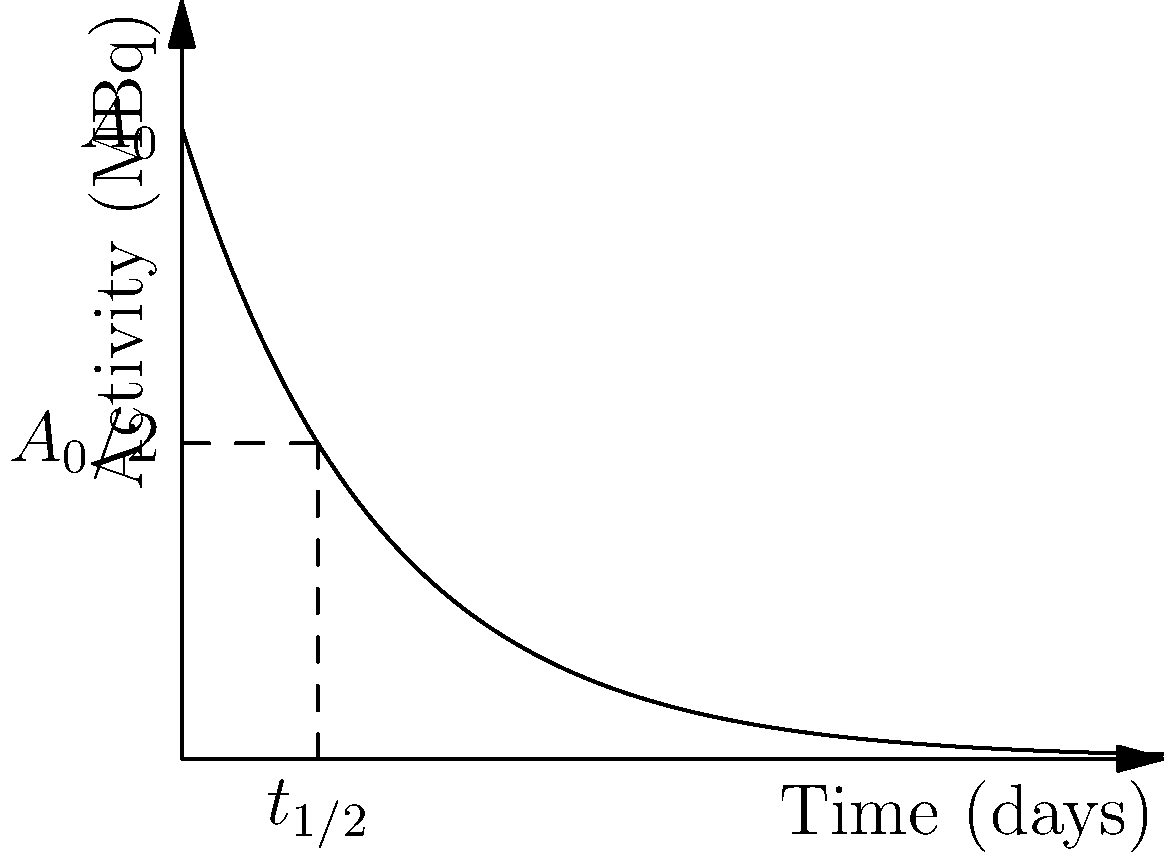A radioactive isotope used in medical treatments follows the decay curve shown in the graph. If the initial activity is 100 MBq, what will be the approximate activity after 20 days? How does this relate to the isotope's half-life? To solve this problem, we need to follow these steps:

1) First, we identify the decay constant $\lambda$ from the graph. The curve follows the equation $A(t) = A_0 e^{-\lambda t}$.

2) We can see that the half-life $t_{1/2}$ is about 6.93 days. The relationship between half-life and decay constant is:

   $t_{1/2} = \frac{\ln(2)}{\lambda}$

3) Solving for $\lambda$:
   
   $\lambda = \frac{\ln(2)}{t_{1/2}} = \frac{\ln(2)}{6.93} \approx 0.1$ day$^{-1}$

4) Now we can use the decay equation to find the activity after 20 days:

   $A(20) = A_0 e^{-\lambda t} = 100 \cdot e^{-0.1 \cdot 20} \approx 13.5$ MBq

5) To relate this to the half-life: After 20 days, which is about 2.89 half-lives (20/6.93), we expect the activity to be reduced by a factor of $2^{2.89} \approx 7.4$. 

   Indeed, 100 MBq / 7.4 ≈ 13.5 MBq, confirming our calculation.

This shows how the concept of half-life directly relates to the decay curve and can be used to predict the activity of a radioactive sample at any given time.
Answer: 13.5 MBq; activity halves every 6.93 days 